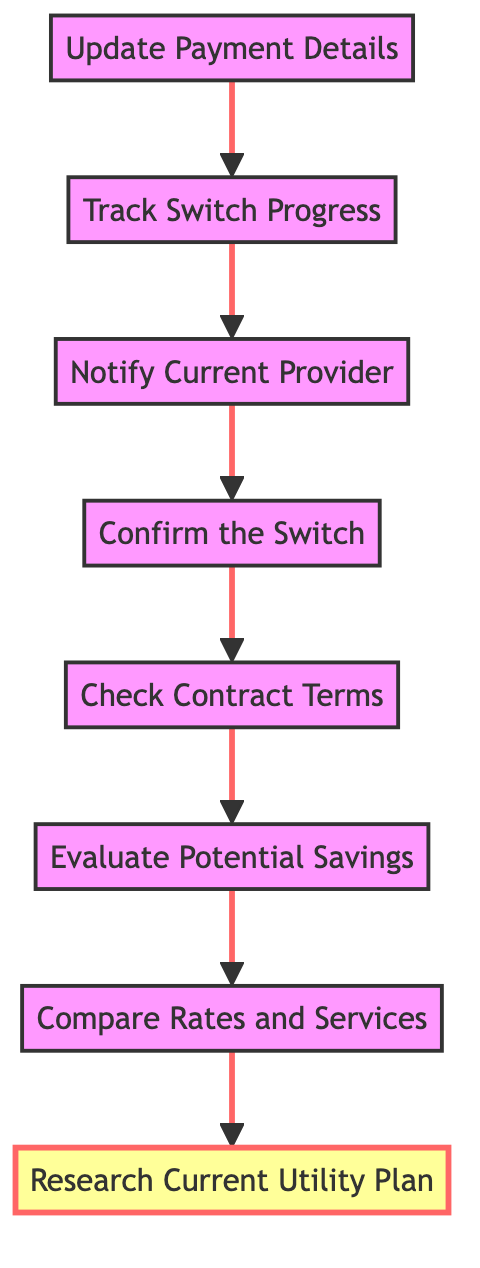What's the first step in the diagram? The first step in the diagram is labeled "Research Current Utility Plan," indicating it's the starting point of the process. Since this is a flowchart, the first element is typically positioned at the bottom and connects to the next steps.
Answer: Research Current Utility Plan How many nodes are in the diagram? The diagram contains a total of eight nodes, as each step in the process is represented by a distinct node, numbered from the first "Research Current Utility Plan" to the last "Update Payment Details."
Answer: 8 What is the last step in the flowchart? The last step in the flowchart is "Update Payment Details," which indicates the final action to be taken in the process of switching utility providers. This is seen at the top of the diagram, marking the conclusion of the workflow.
Answer: Update Payment Details Which node comes after "Check Contract Terms"? The node that follows "Check Contract Terms" is "Confirm the Switch." This indicates that after reviewing contract terms, the next action is to confirm the switch with the new provider.
Answer: Confirm the Switch What are the two nodes connected directly before "Notify Current Provider"? The two nodes that connect directly before "Notify Current Provider" are "Confirm the Switch" and "Track Switch Progress." This shows the sequence of steps leading to notifying the current utility provider.
Answer: Confirm the Switch, Track Switch Progress What is the relationship between "Evaluate Potential Savings" and "Compare Rates and Services"? "Evaluate Potential Savings" comes after "Compare Rates and Services," meaning that one must compare rates first before evaluating the potential savings from switching providers. This provides a logical flow of information and decision-making.
Answer: Sequential relationship How many edges connect all nodes in the diagram? There are seven edges connecting all nodes in the diagram. Each step flows into the next, creating a linear progression from the starting point to the endpoint, totaling seven connections.
Answer: 7 What item must a person ensure continuity of service for? A person must ensure continuity of service for "Update Payment Details." This step is crucial because without properly updating payment information, service disruption could occur when switching utility providers.
Answer: Update Payment Details 